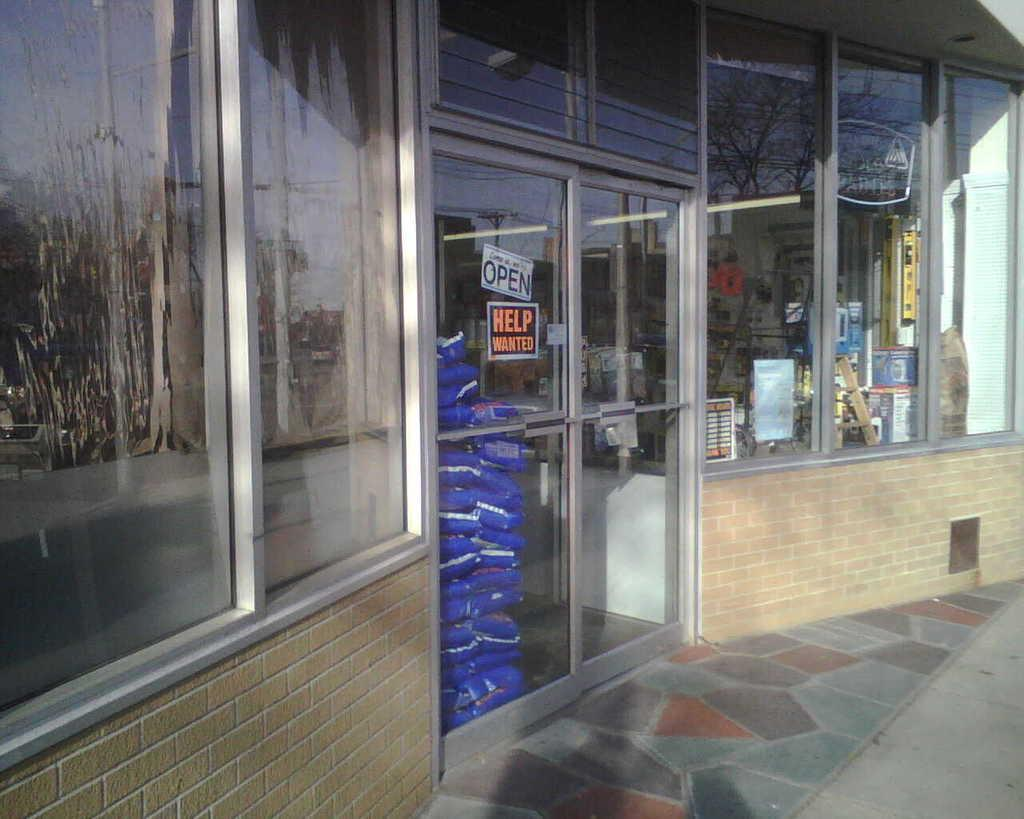<image>
Describe the image concisely. the help wanted sign is outside of a store area 